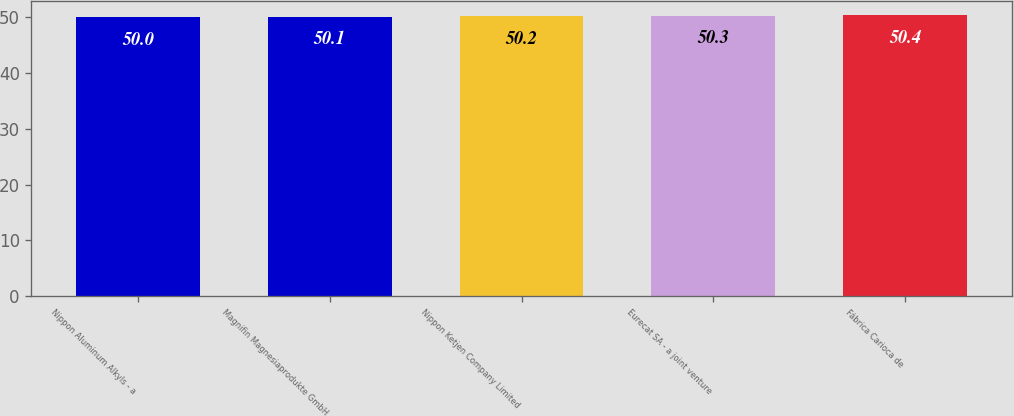Convert chart. <chart><loc_0><loc_0><loc_500><loc_500><bar_chart><fcel>Nippon Aluminum Alkyls - a<fcel>Magnifin Magnesiaprodukte GmbH<fcel>Nippon Ketjen Company Limited<fcel>Eurecat SA - a joint venture<fcel>Fábrica Carioca de<nl><fcel>50<fcel>50.1<fcel>50.2<fcel>50.3<fcel>50.4<nl></chart> 